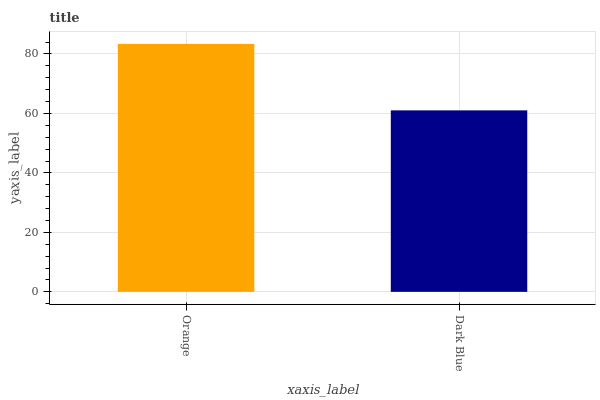Is Dark Blue the minimum?
Answer yes or no. Yes. Is Orange the maximum?
Answer yes or no. Yes. Is Dark Blue the maximum?
Answer yes or no. No. Is Orange greater than Dark Blue?
Answer yes or no. Yes. Is Dark Blue less than Orange?
Answer yes or no. Yes. Is Dark Blue greater than Orange?
Answer yes or no. No. Is Orange less than Dark Blue?
Answer yes or no. No. Is Orange the high median?
Answer yes or no. Yes. Is Dark Blue the low median?
Answer yes or no. Yes. Is Dark Blue the high median?
Answer yes or no. No. Is Orange the low median?
Answer yes or no. No. 